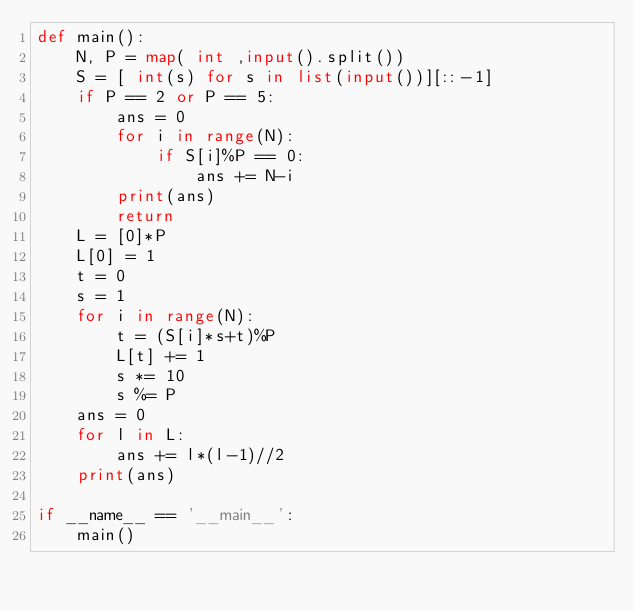Convert code to text. <code><loc_0><loc_0><loc_500><loc_500><_Python_>def main():
    N, P = map( int ,input().split())
    S = [ int(s) for s in list(input())][::-1]
    if P == 2 or P == 5:
        ans = 0
        for i in range(N):
            if S[i]%P == 0:
                ans += N-i
        print(ans)
        return
    L = [0]*P
    L[0] = 1
    t = 0
    s = 1
    for i in range(N):
        t = (S[i]*s+t)%P
        L[t] += 1
        s *= 10
        s %= P
    ans = 0
    for l in L:
        ans += l*(l-1)//2
    print(ans)
    
if __name__ == '__main__':
    main()
</code> 